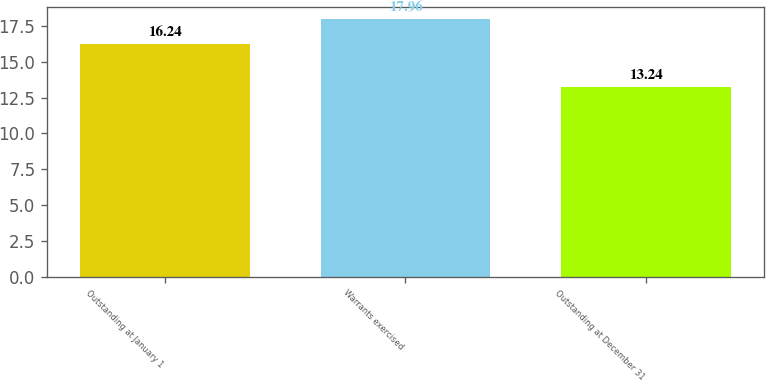Convert chart to OTSL. <chart><loc_0><loc_0><loc_500><loc_500><bar_chart><fcel>Outstanding at January 1<fcel>Warrants exercised<fcel>Outstanding at December 31<nl><fcel>16.24<fcel>17.96<fcel>13.24<nl></chart> 